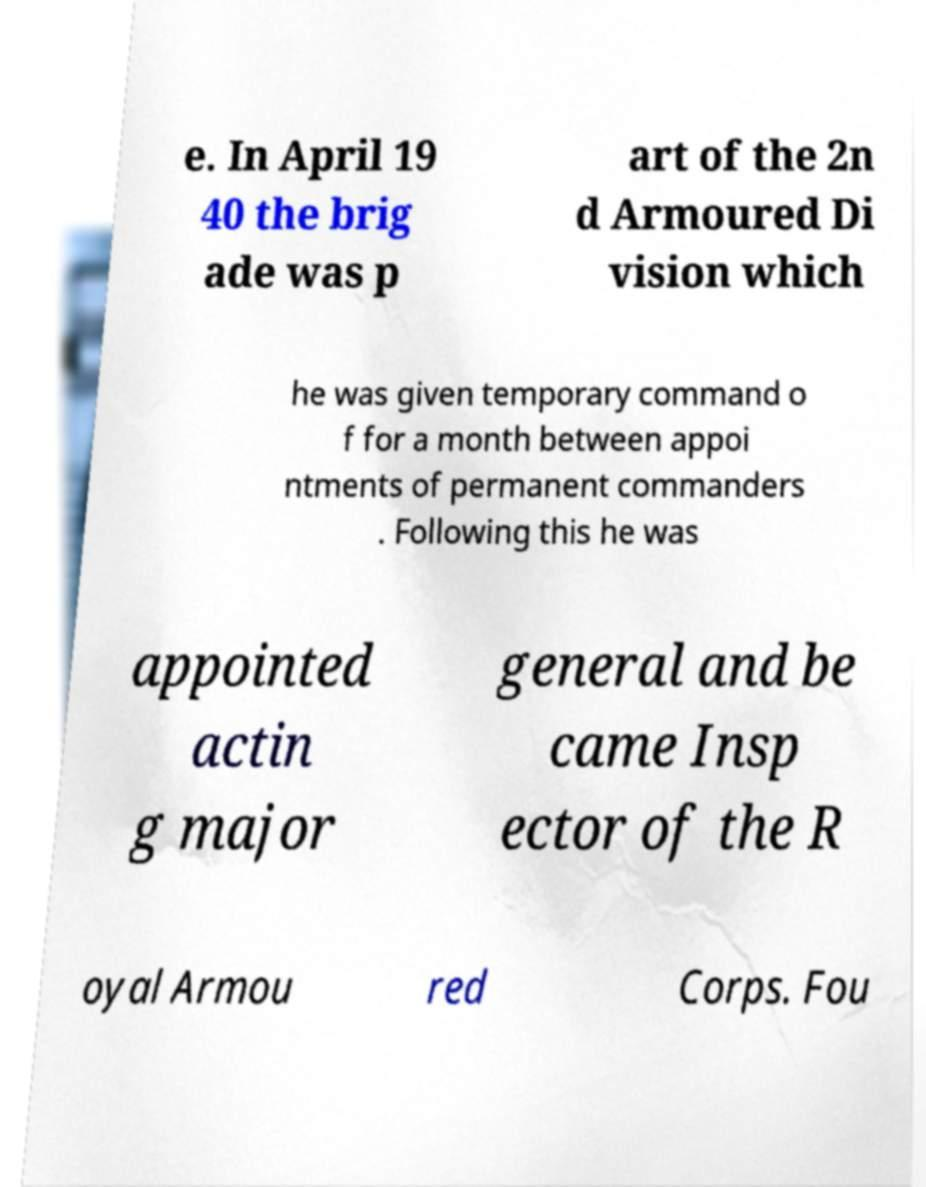Could you extract and type out the text from this image? e. In April 19 40 the brig ade was p art of the 2n d Armoured Di vision which he was given temporary command o f for a month between appoi ntments of permanent commanders . Following this he was appointed actin g major general and be came Insp ector of the R oyal Armou red Corps. Fou 